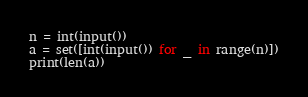Convert code to text. <code><loc_0><loc_0><loc_500><loc_500><_Python_>n = int(input())
a = set([int(input()) for _ in range(n)])
print(len(a))
</code> 